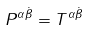<formula> <loc_0><loc_0><loc_500><loc_500>P ^ { \alpha \dot { \beta } } = T ^ { \alpha \dot { \beta } }</formula> 